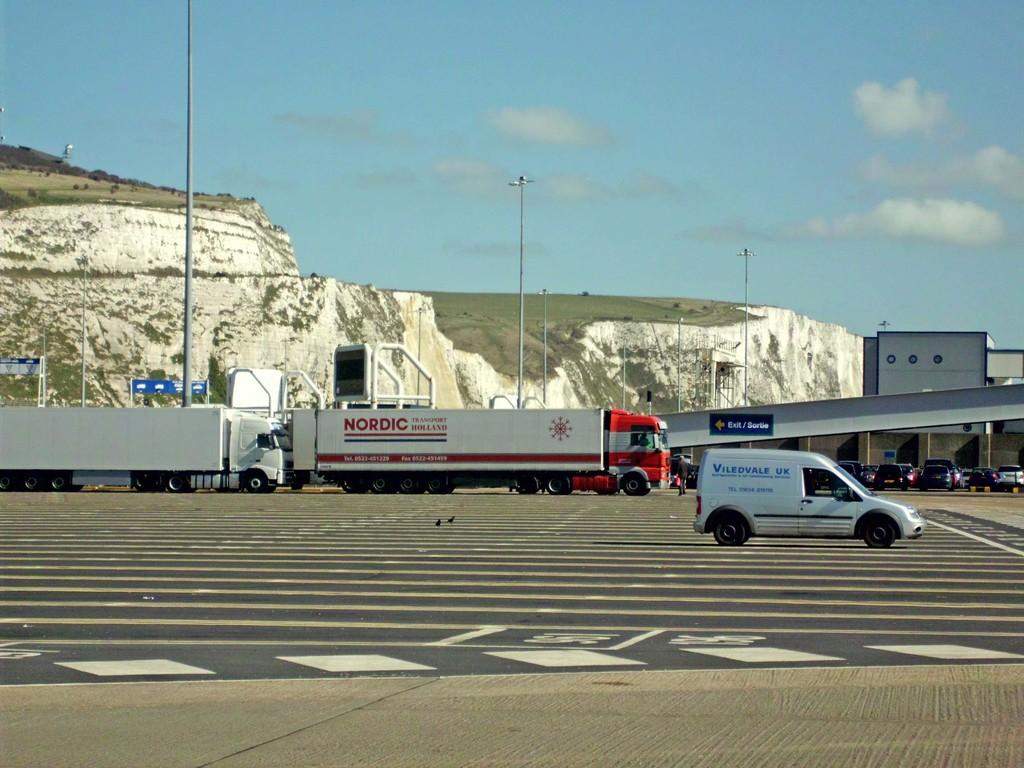What types of vehicles can be seen in the image? There are trucks, cars, and other vehicles in the image. Where are these vehicles located? These vehicles are on the road. What else can be seen in the image besides vehicles? There are rocks and poles visible in the image. What type of soda is being advertised on the range in the image? There is no range or soda present in the image; it features vehicles on the road with rocks and poles nearby. 